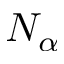Convert formula to latex. <formula><loc_0><loc_0><loc_500><loc_500>N _ { \alpha }</formula> 